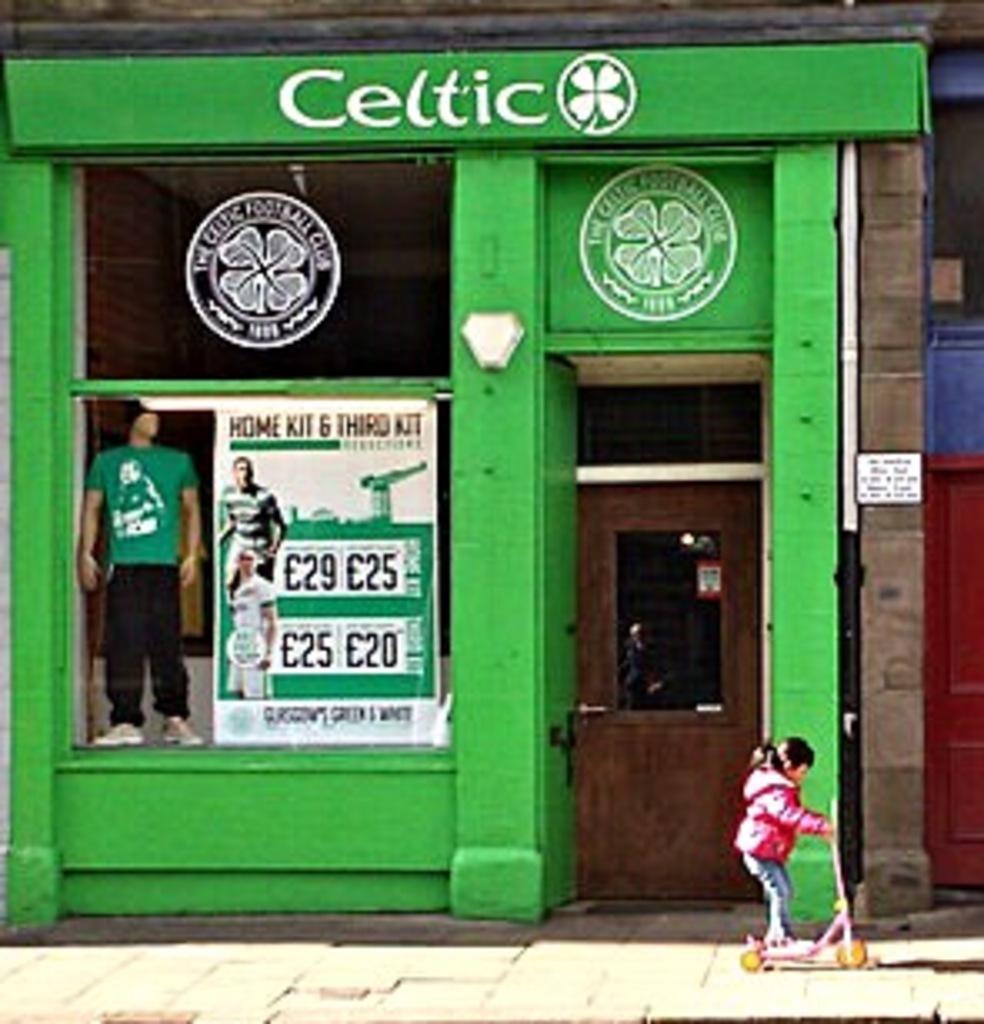How would you summarize this image in a sentence or two? This picture shows a store and we see a girl playing with a foot scooter and we see a mannequin and a poster and we see a door. 